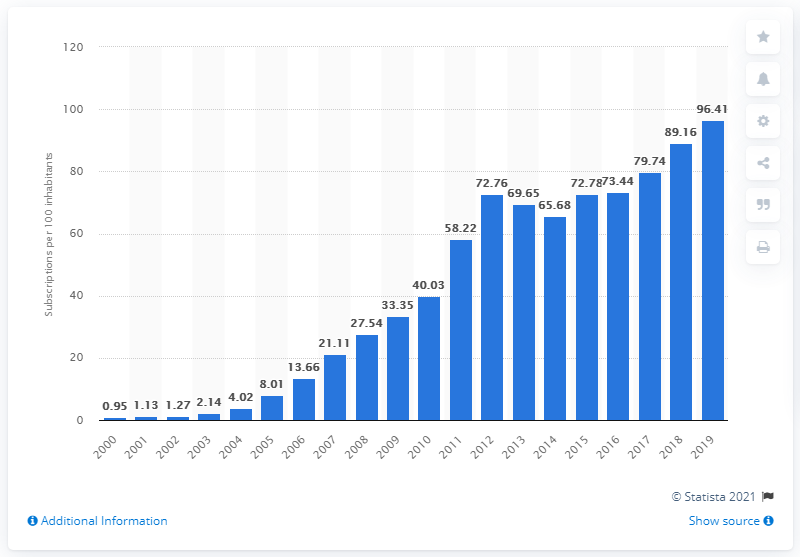Identify some key points in this picture. The number of mobile cellular subscriptions per 100 inhabitants in Zambia was between 2000 and 2021. In Zambia, between 2000 and 2019, there were an average of 96.41 mobile subscriptions for every 100 people. 